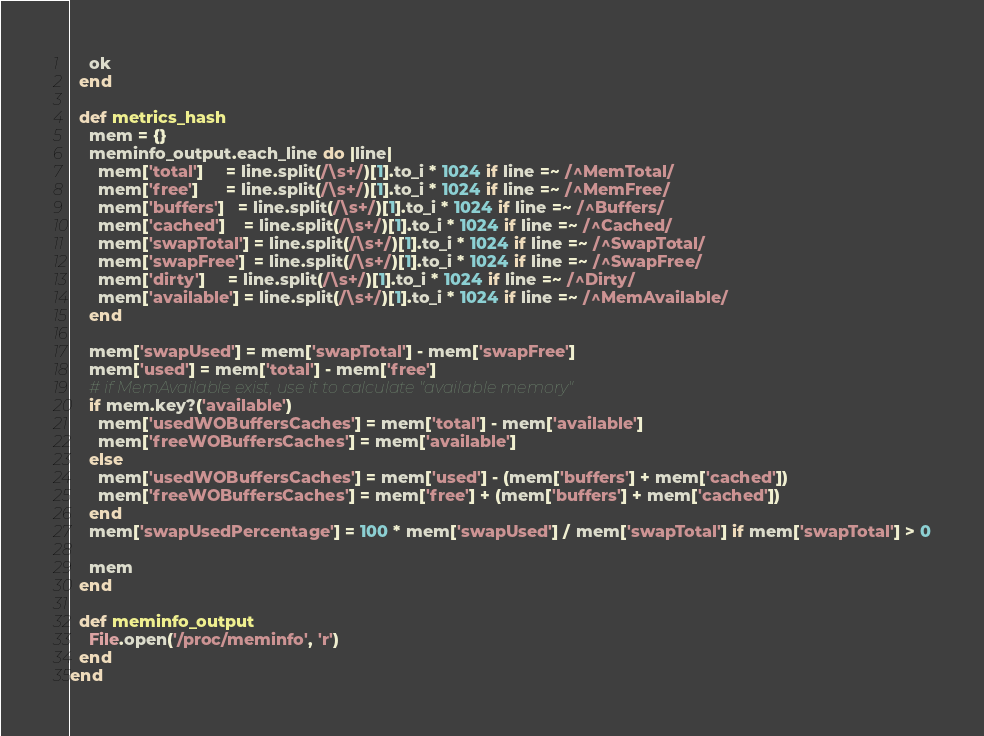<code> <loc_0><loc_0><loc_500><loc_500><_Ruby_>    ok
  end

  def metrics_hash
    mem = {}
    meminfo_output.each_line do |line|
      mem['total']     = line.split(/\s+/)[1].to_i * 1024 if line =~ /^MemTotal/
      mem['free']      = line.split(/\s+/)[1].to_i * 1024 if line =~ /^MemFree/
      mem['buffers']   = line.split(/\s+/)[1].to_i * 1024 if line =~ /^Buffers/
      mem['cached']    = line.split(/\s+/)[1].to_i * 1024 if line =~ /^Cached/
      mem['swapTotal'] = line.split(/\s+/)[1].to_i * 1024 if line =~ /^SwapTotal/
      mem['swapFree']  = line.split(/\s+/)[1].to_i * 1024 if line =~ /^SwapFree/
      mem['dirty']     = line.split(/\s+/)[1].to_i * 1024 if line =~ /^Dirty/
      mem['available'] = line.split(/\s+/)[1].to_i * 1024 if line =~ /^MemAvailable/
    end

    mem['swapUsed'] = mem['swapTotal'] - mem['swapFree']
    mem['used'] = mem['total'] - mem['free']
    # if MemAvailable exist, use it to calculate "available memory"
    if mem.key?('available')
      mem['usedWOBuffersCaches'] = mem['total'] - mem['available']
      mem['freeWOBuffersCaches'] = mem['available']
    else
      mem['usedWOBuffersCaches'] = mem['used'] - (mem['buffers'] + mem['cached'])
      mem['freeWOBuffersCaches'] = mem['free'] + (mem['buffers'] + mem['cached'])
    end
    mem['swapUsedPercentage'] = 100 * mem['swapUsed'] / mem['swapTotal'] if mem['swapTotal'] > 0

    mem
  end

  def meminfo_output
    File.open('/proc/meminfo', 'r')
  end
end
</code> 